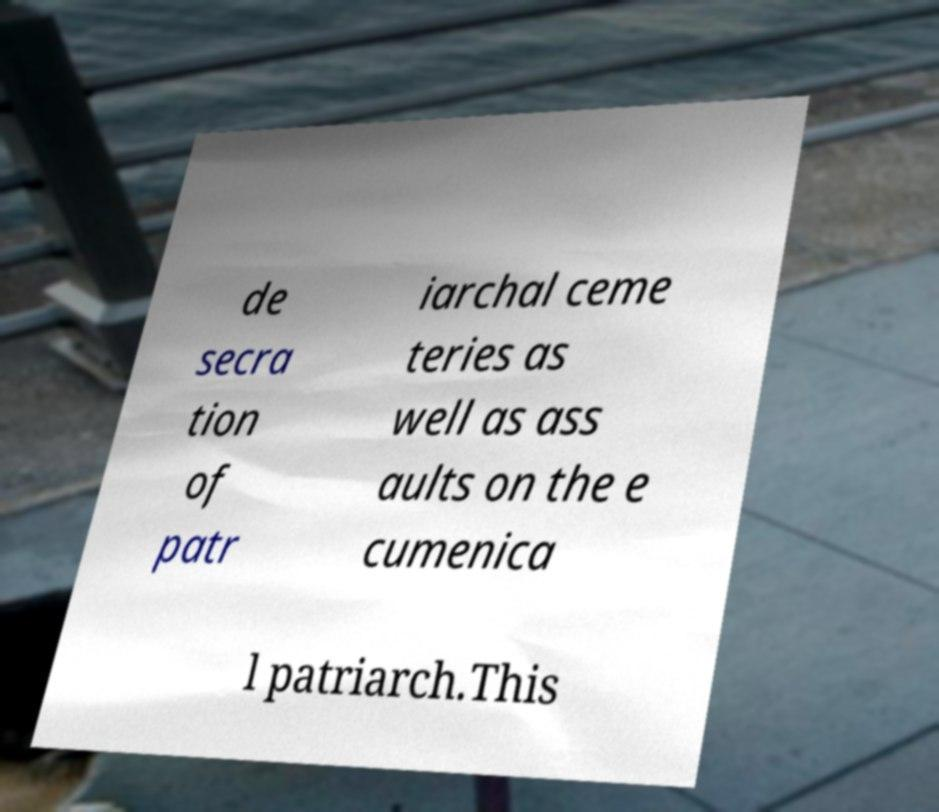Can you read and provide the text displayed in the image?This photo seems to have some interesting text. Can you extract and type it out for me? de secra tion of patr iarchal ceme teries as well as ass aults on the e cumenica l patriarch.This 